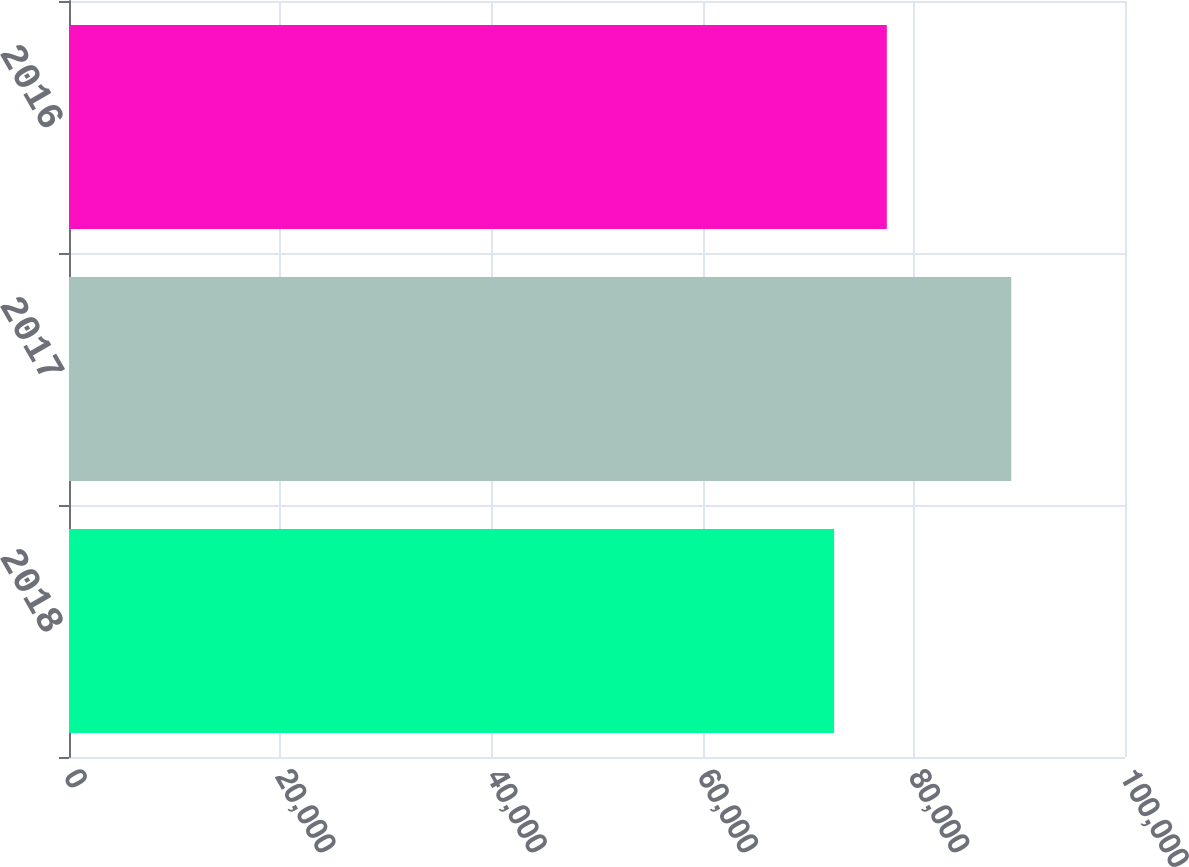Convert chart to OTSL. <chart><loc_0><loc_0><loc_500><loc_500><bar_chart><fcel>2018<fcel>2017<fcel>2016<nl><fcel>72454<fcel>89226<fcel>77445<nl></chart> 